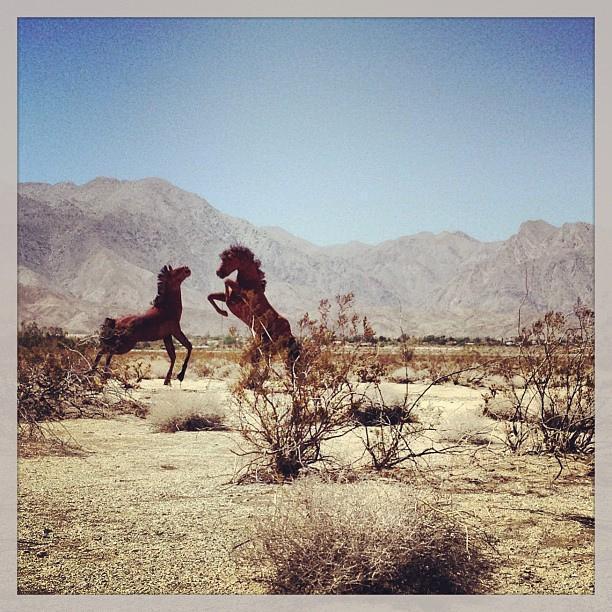How many feet is the horse on the right standing on?
Give a very brief answer. 2. How many horses can be seen?
Give a very brief answer. 2. 